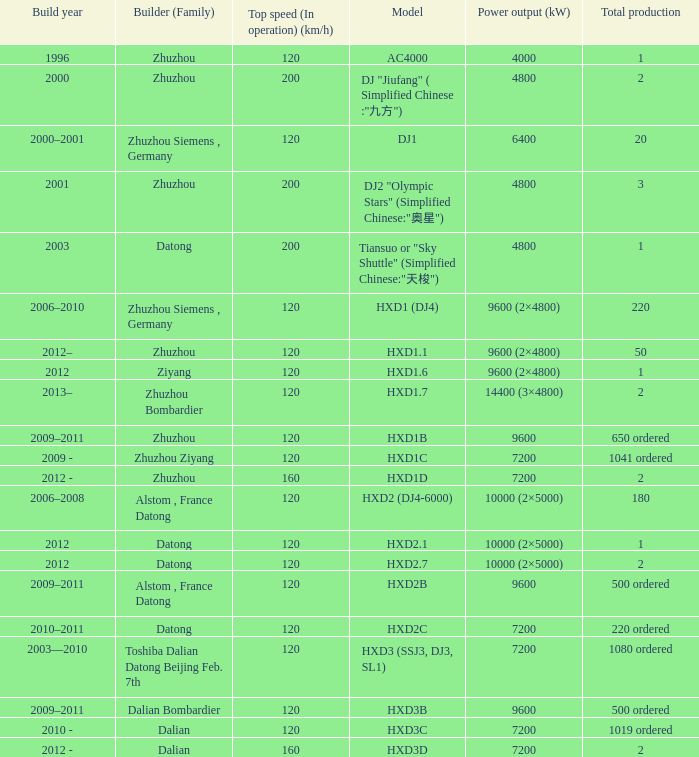Help me parse the entirety of this table. {'header': ['Build year', 'Builder (Family)', 'Top speed (In operation) (km/h)', 'Model', 'Power output (kW)', 'Total production'], 'rows': [['1996', 'Zhuzhou', '120', 'AC4000', '4000', '1'], ['2000', 'Zhuzhou', '200', 'DJ "Jiufang" ( Simplified Chinese :"九方")', '4800', '2'], ['2000–2001', 'Zhuzhou Siemens , Germany', '120', 'DJ1', '6400', '20'], ['2001', 'Zhuzhou', '200', 'DJ2 "Olympic Stars" (Simplified Chinese:"奥星")', '4800', '3'], ['2003', 'Datong', '200', 'Tiansuo or "Sky Shuttle" (Simplified Chinese:"天梭")', '4800', '1'], ['2006–2010', 'Zhuzhou Siemens , Germany', '120', 'HXD1 (DJ4)', '9600 (2×4800)', '220'], ['2012–', 'Zhuzhou', '120', 'HXD1.1', '9600 (2×4800)', '50'], ['2012', 'Ziyang', '120', 'HXD1.6', '9600 (2×4800)', '1'], ['2013–', 'Zhuzhou Bombardier', '120', 'HXD1.7', '14400 (3×4800)', '2'], ['2009–2011', 'Zhuzhou', '120', 'HXD1B', '9600', '650 ordered'], ['2009 -', 'Zhuzhou Ziyang', '120', 'HXD1C', '7200', '1041 ordered'], ['2012 -', 'Zhuzhou', '160', 'HXD1D', '7200', '2'], ['2006–2008', 'Alstom , France Datong', '120', 'HXD2 (DJ4-6000)', '10000 (2×5000)', '180'], ['2012', 'Datong', '120', 'HXD2.1', '10000 (2×5000)', '1'], ['2012', 'Datong', '120', 'HXD2.7', '10000 (2×5000)', '2'], ['2009–2011', 'Alstom , France Datong', '120', 'HXD2B', '9600', '500 ordered'], ['2010–2011', 'Datong', '120', 'HXD2C', '7200', '220 ordered'], ['2003—2010', 'Toshiba Dalian Datong Beijing Feb. 7th', '120', 'HXD3 (SSJ3, DJ3, SL1)', '7200', '1080 ordered'], ['2009–2011', 'Dalian Bombardier', '120', 'HXD3B', '9600', '500 ordered'], ['2010 -', 'Dalian', '120', 'HXD3C', '7200', '1019 ordered'], ['2012 -', 'Dalian', '160', 'HXD3D', '7200', '2']]} What model has a builder of zhuzhou, and a power output of 9600 (kw)? HXD1B. 